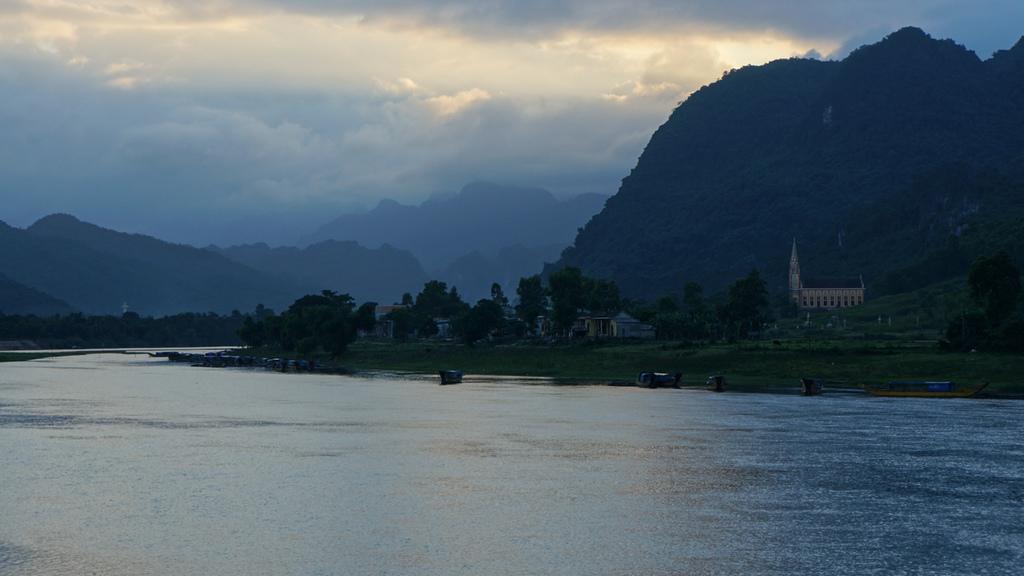Please provide a concise description of this image. In this image we can see group of buildings ,trees ,water. In the background we can see mountains and a cloudy sky. 